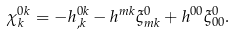Convert formula to latex. <formula><loc_0><loc_0><loc_500><loc_500>\chi _ { k } ^ { 0 k } = - h _ { , k } ^ { 0 k } - h ^ { m k } \xi _ { m k } ^ { 0 } + h ^ { 0 0 } \xi _ { 0 0 } ^ { 0 } .</formula> 